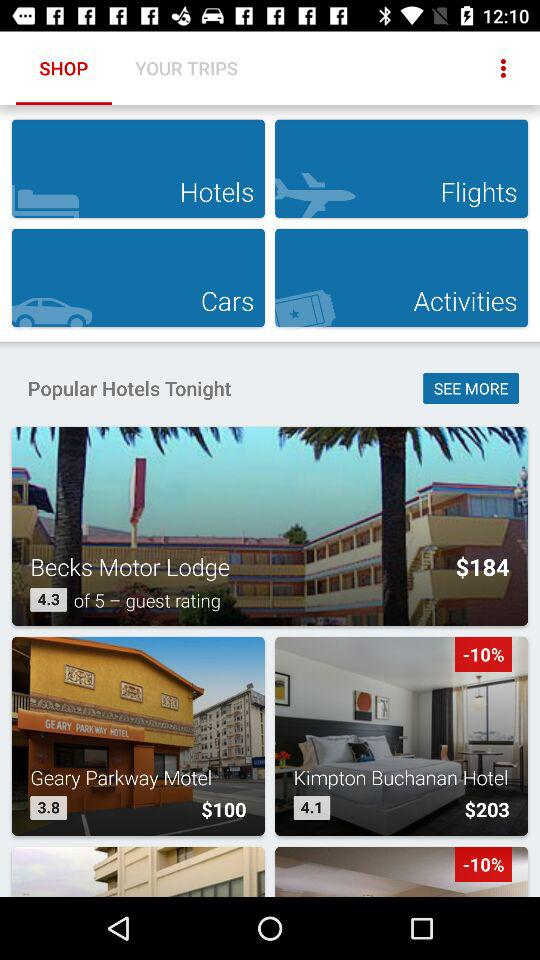What hotel's booking price is $100 for a room? The hotel whose booking price is $100 for a room is the "Geary Parkway Motel". 